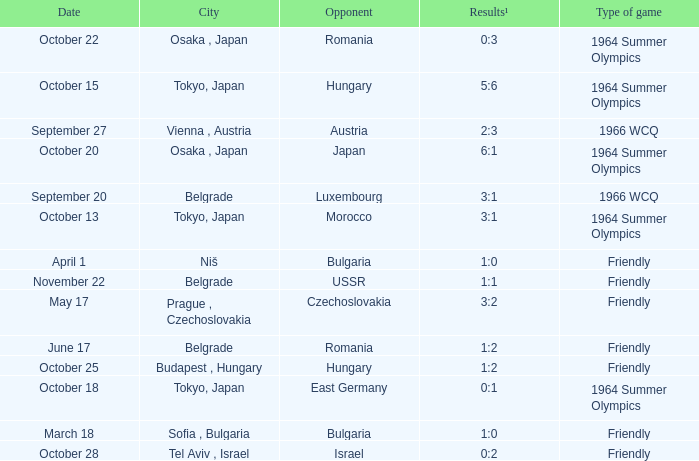Wjich city had a date of october 13? Tokyo, Japan. 